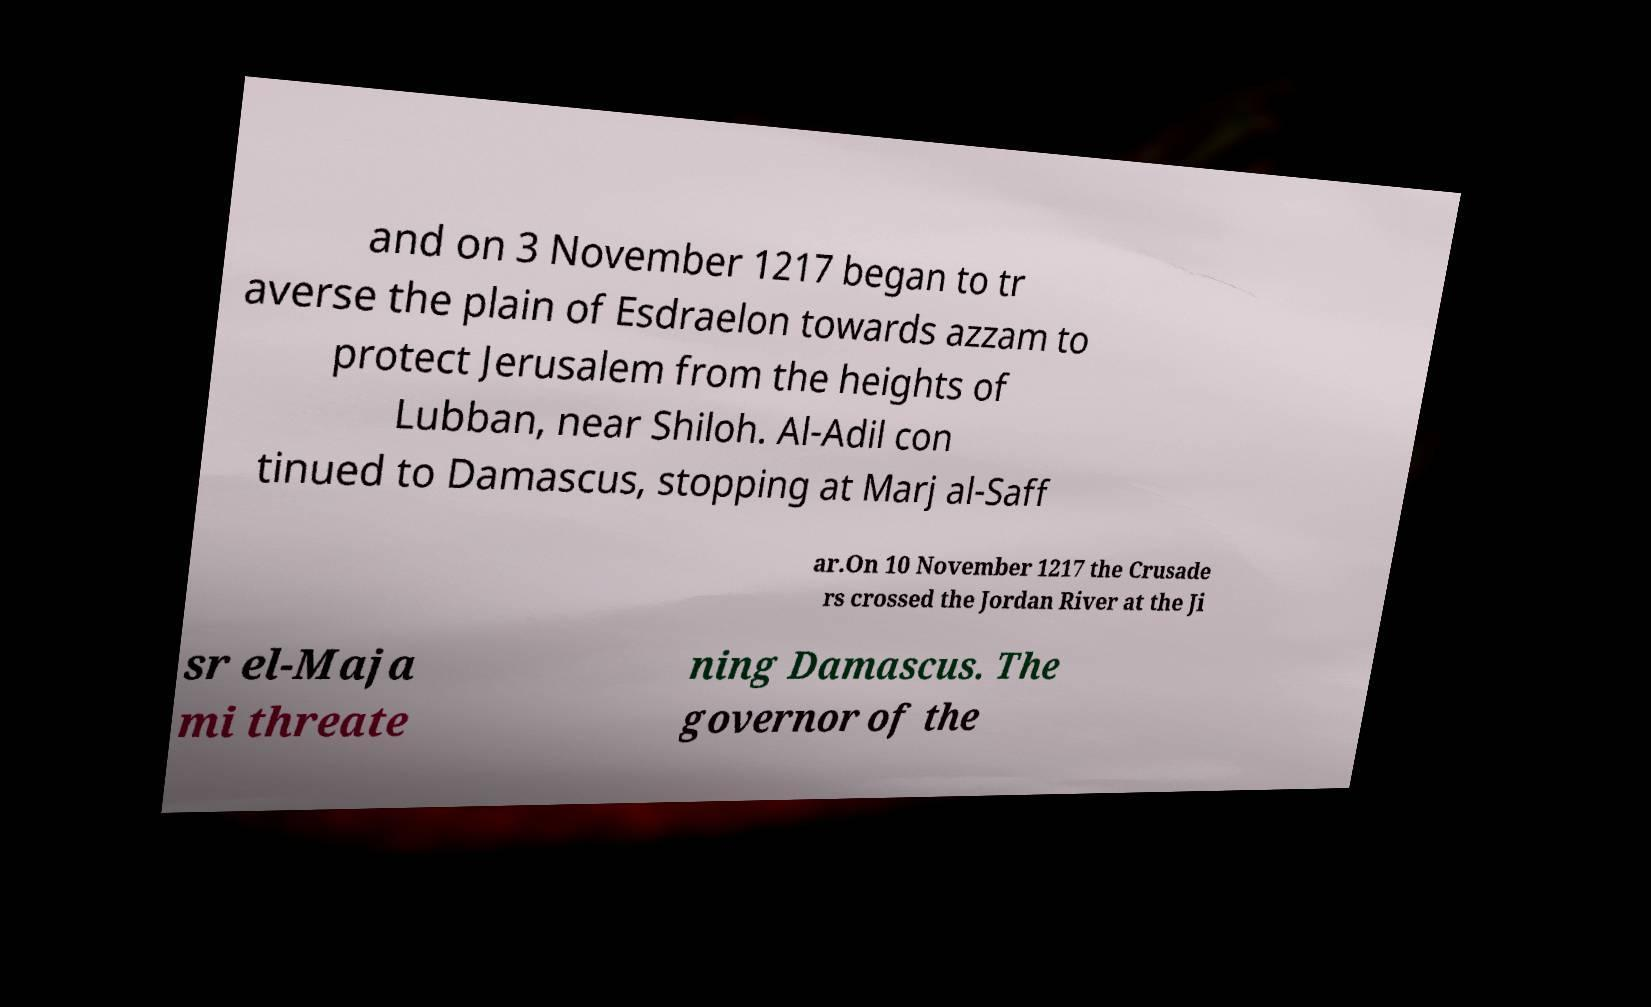Please identify and transcribe the text found in this image. and on 3 November 1217 began to tr averse the plain of Esdraelon towards azzam to protect Jerusalem from the heights of Lubban, near Shiloh. Al-Adil con tinued to Damascus, stopping at Marj al-Saff ar.On 10 November 1217 the Crusade rs crossed the Jordan River at the Ji sr el-Maja mi threate ning Damascus. The governor of the 